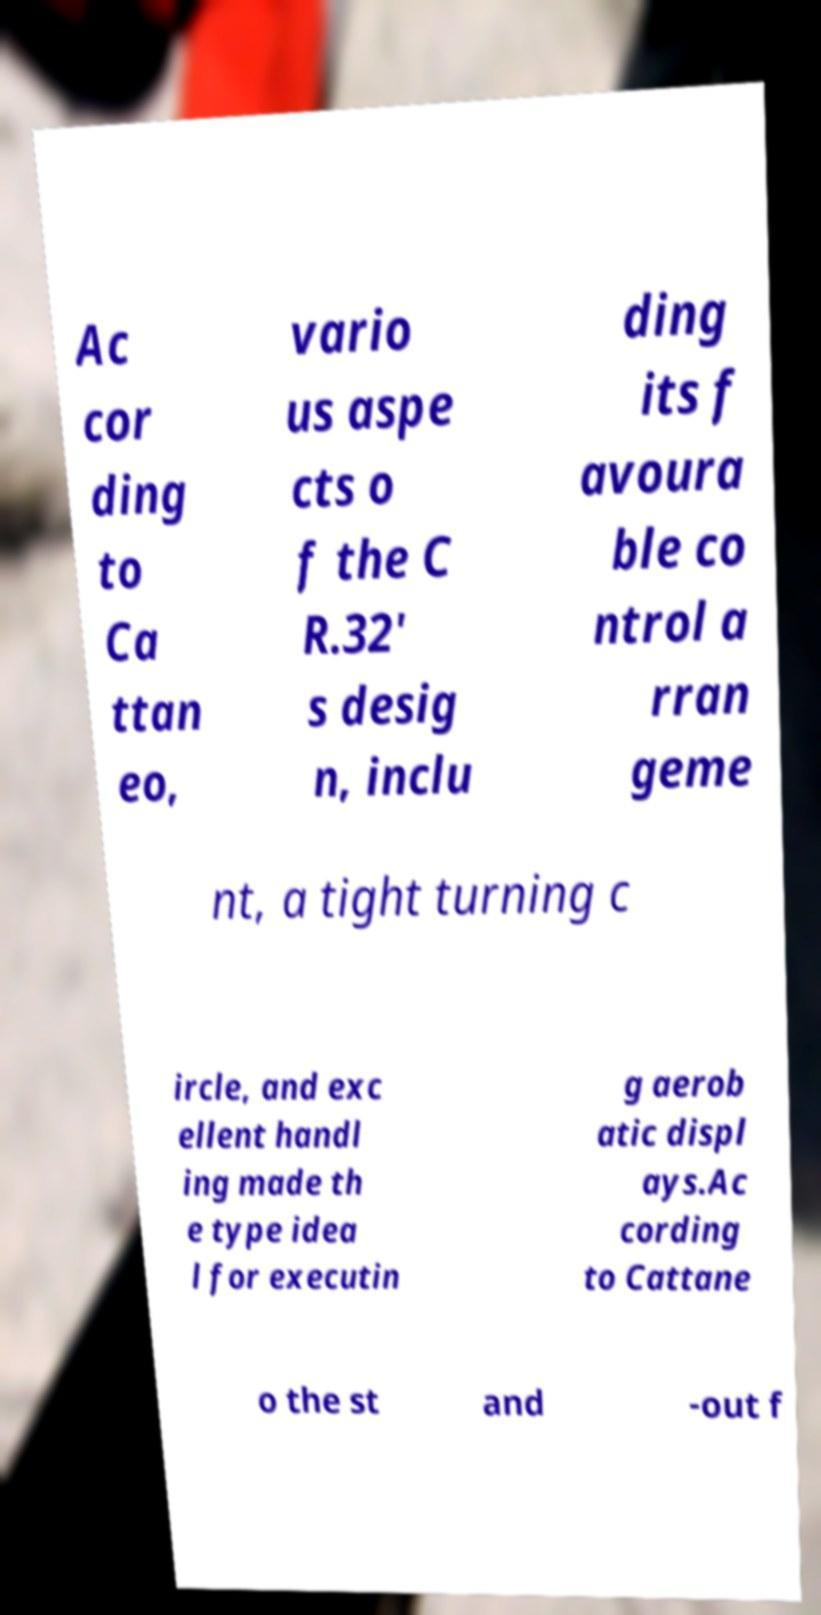Can you accurately transcribe the text from the provided image for me? Ac cor ding to Ca ttan eo, vario us aspe cts o f the C R.32' s desig n, inclu ding its f avoura ble co ntrol a rran geme nt, a tight turning c ircle, and exc ellent handl ing made th e type idea l for executin g aerob atic displ ays.Ac cording to Cattane o the st and -out f 